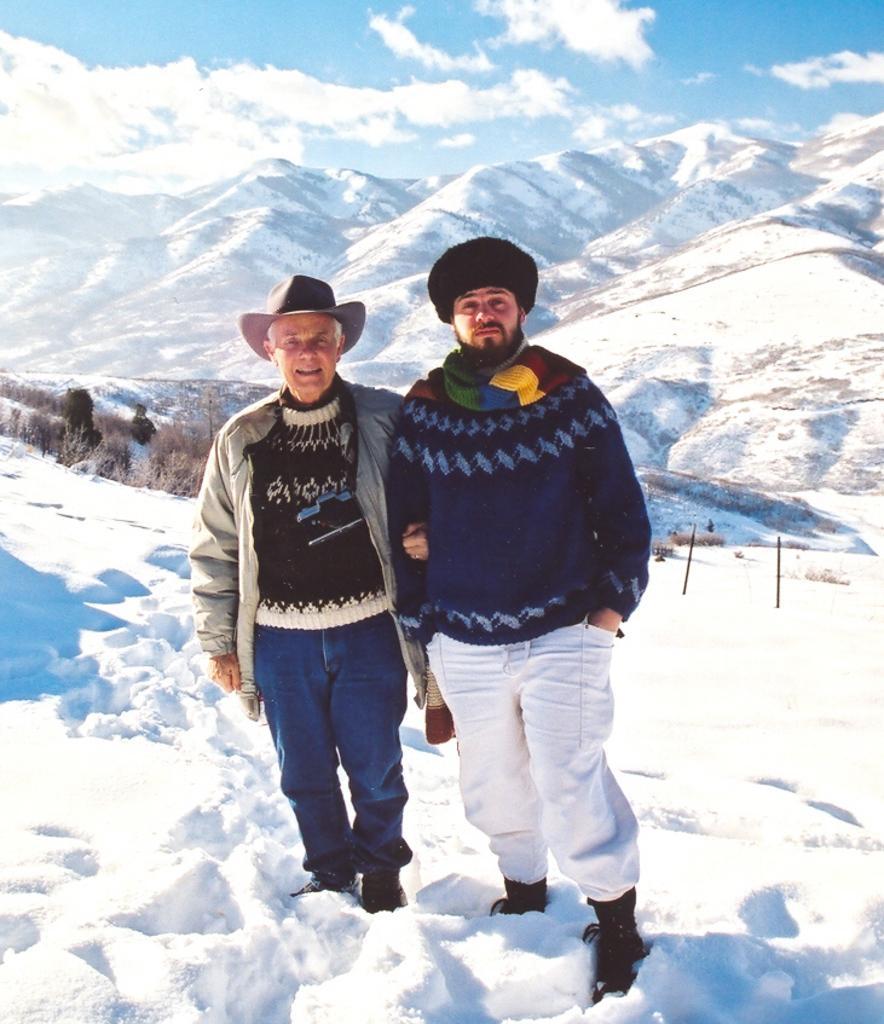In one or two sentences, can you explain what this image depicts? In the middle of this image, there are two persons standing on a snowy surface. In the background, there are trees, mountains and there are clouds in the sky. 